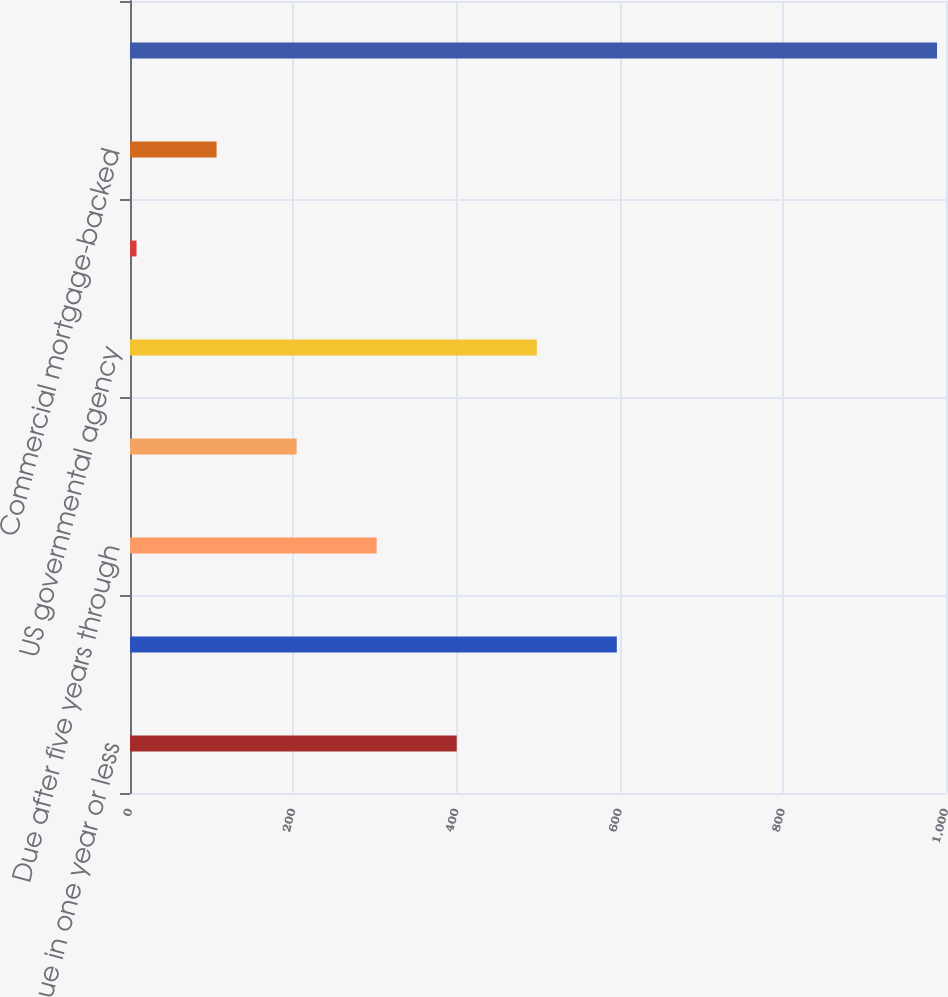Convert chart to OTSL. <chart><loc_0><loc_0><loc_500><loc_500><bar_chart><fcel>Due in one year or less<fcel>Due after one year through<fcel>Due after five years through<fcel>Due after ten years<fcel>US governmental agency<fcel>Residential mortgage-backed<fcel>Commercial mortgage-backed<fcel>Total debt securities -<nl><fcel>400.4<fcel>596.6<fcel>302.3<fcel>204.2<fcel>498.5<fcel>8<fcel>106.1<fcel>989<nl></chart> 